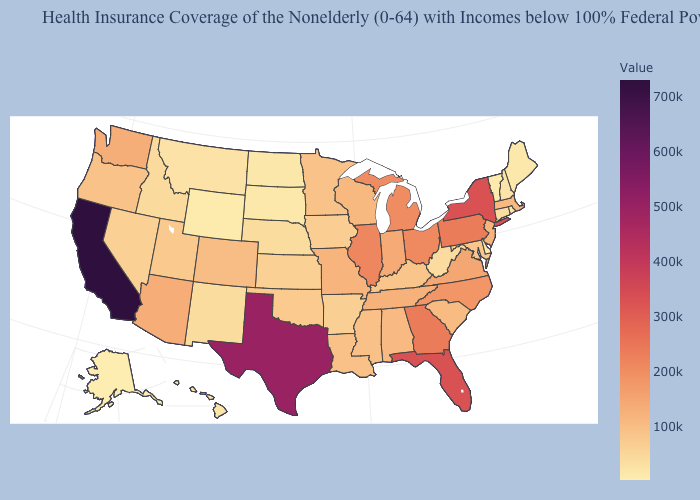Does Maryland have a higher value than Alaska?
Concise answer only. Yes. Which states hav the highest value in the MidWest?
Be succinct. Illinois. Does Delaware have the lowest value in the South?
Write a very short answer. Yes. Which states hav the highest value in the Northeast?
Write a very short answer. New York. 